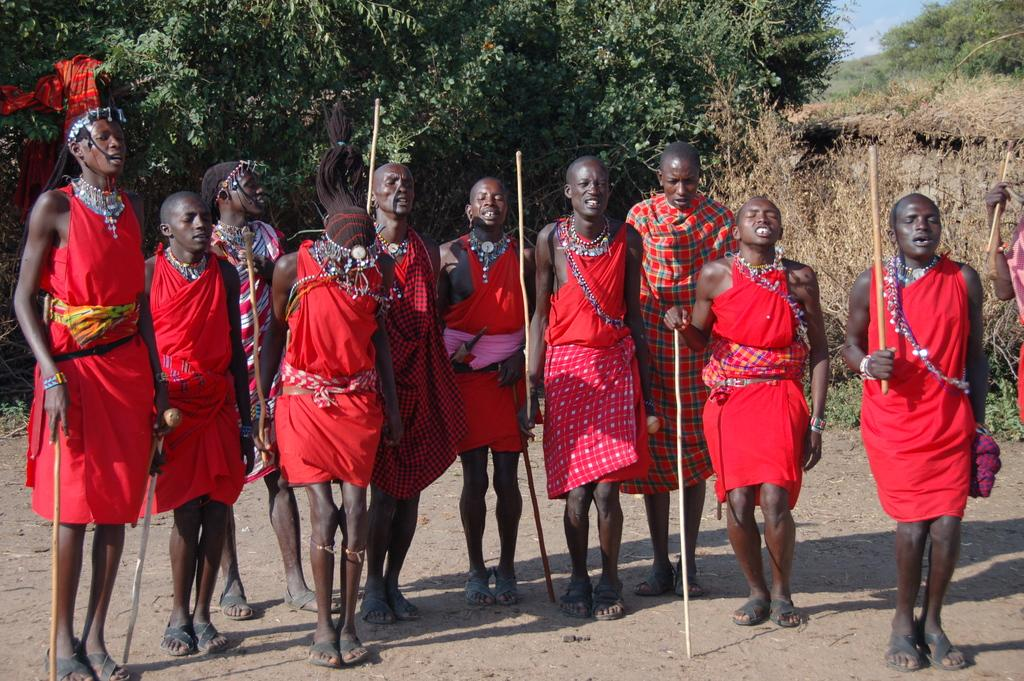What is happening in the image involving a group of people? There is a group of people in the image, and they are standing. What are the people holding in their hands? The people are holding a stick in their hands. What can be seen in the background of the image? There are trees and clouds in the sky in the background of the image. What type of appliance is being used by the people in the image? There is no appliance visible in the image; the people are holding a stick in their hands. What type of competition is taking place in the image? There is no competition depicted in the image; it simply shows a group of people standing and holding a stick. 